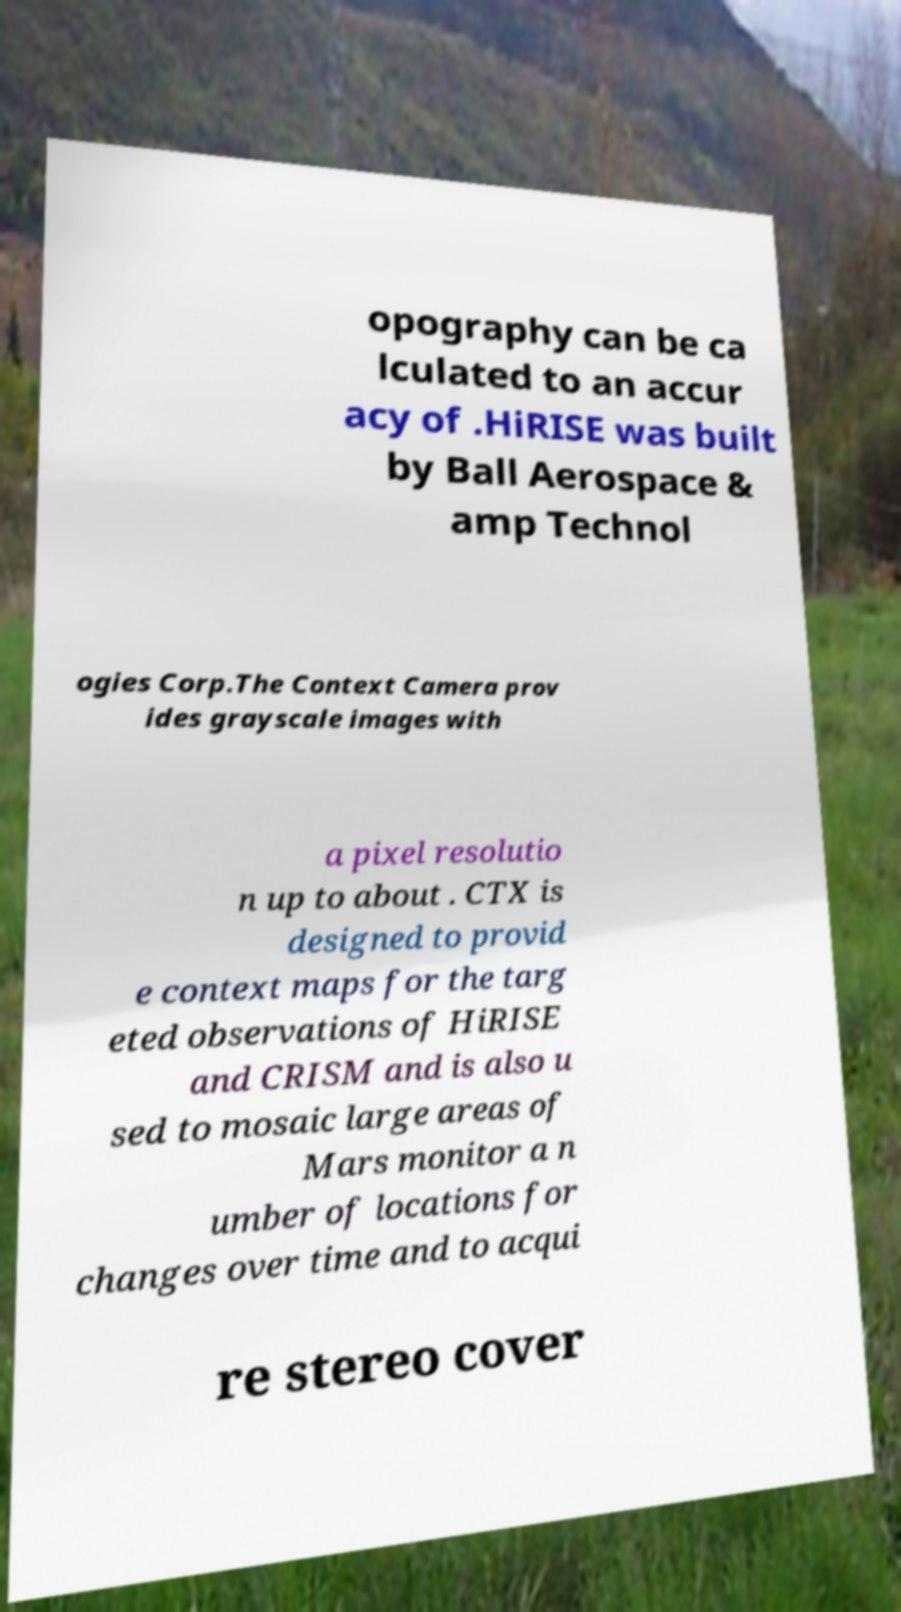For documentation purposes, I need the text within this image transcribed. Could you provide that? opography can be ca lculated to an accur acy of .HiRISE was built by Ball Aerospace & amp Technol ogies Corp.The Context Camera prov ides grayscale images with a pixel resolutio n up to about . CTX is designed to provid e context maps for the targ eted observations of HiRISE and CRISM and is also u sed to mosaic large areas of Mars monitor a n umber of locations for changes over time and to acqui re stereo cover 